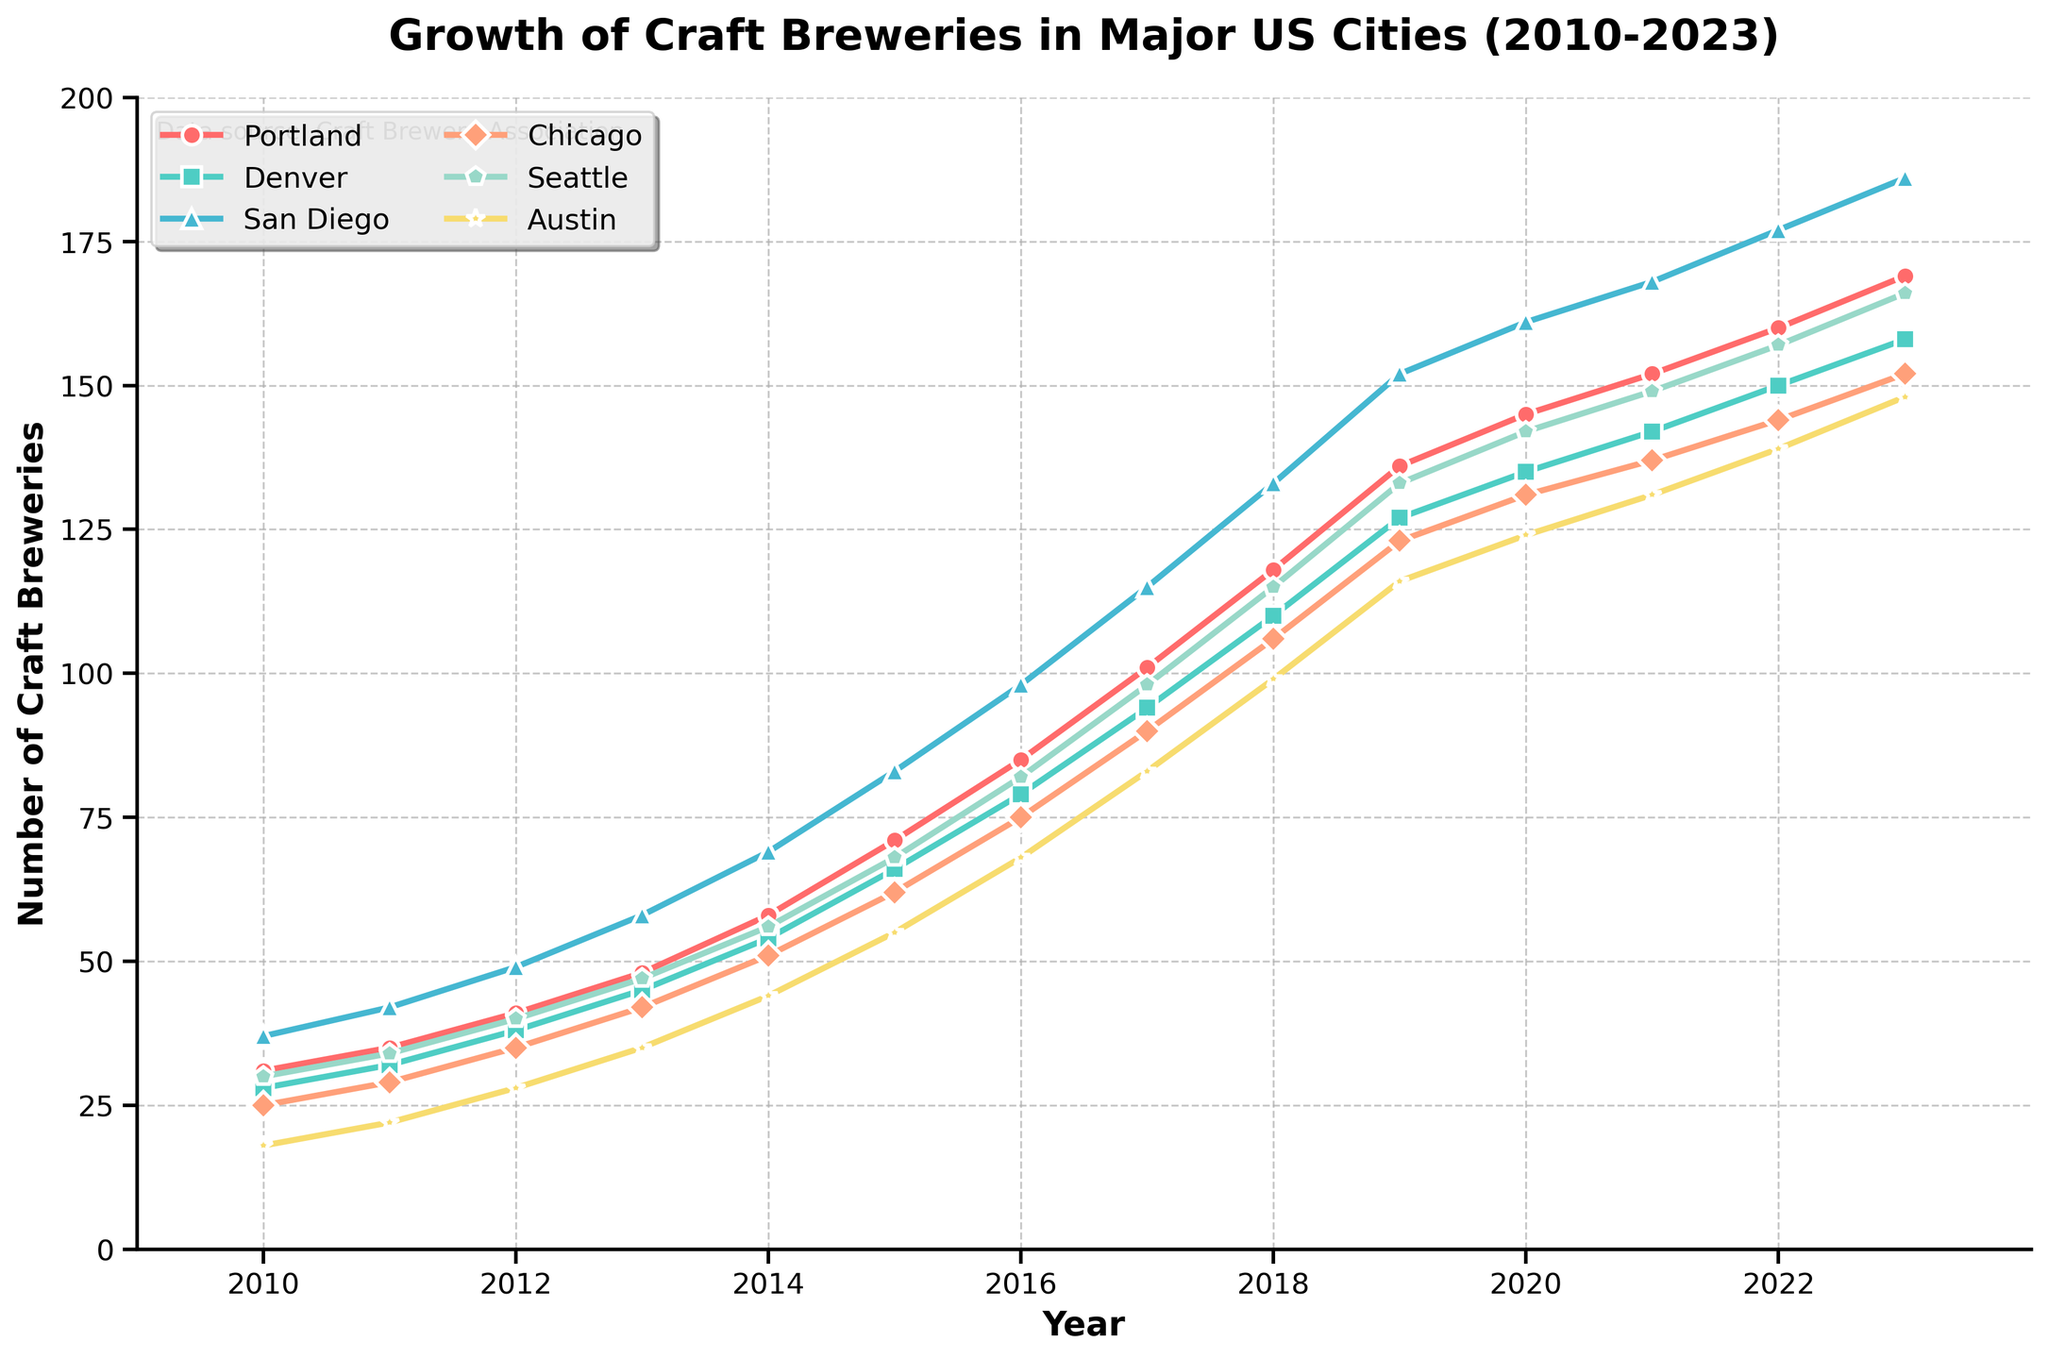What's the city with the highest number of craft breweries in 2023? By observing the endpoints of each line in 2023, we can see the highest point is for San Diego.
Answer: San Diego Compare the number of craft breweries between Denver and Austin in 2015. Which city has more, and by how many? In 2015, Denver has 66 craft breweries while Austin has 55. Subtracting 55 from 66 gives the difference of 11.
Answer: Denver by 11 In which year did Seattle reach 100 craft breweries? By tracking the increasing line for Seattle (greenish-blue line), we see that it crosses the 100 mark in 2017.
Answer: 2017 How many craft breweries were there in total in the six cities combined in 2018? Summing the number of craft breweries for each city in 2018: Portland (118) + Denver (110) + San Diego (133) + Chicago (106) + Seattle (115) + Austin (99) = 681.
Answer: 681 Which city had the most rapid increase in the number of craft breweries between 2010 and 2023? By comparing the slopes, we see San Diego has the steepest overall incline indicating the most rapid increase from 37 in 2010 to 186 in 2023.
Answer: San Diego In 2020, how many craft breweries are there in Chicago compared to Austin? In 2020, Chicago has 131 while Austin has 124. Thus, Chicago has more by 7.
Answer: Chicago by 7 What is the average number of craft breweries in Portland during the years 2010, 2013, and 2016? Adding the number of craft breweries for Portland in these years (31 in 2010, 48 in 2013, and 85 in 2016) and then dividing by 3 gives (31 + 48 + 85) / 3 = 54.67 (approximately).
Answer: 54.67 Which city had the smallest increase in the number of craft breweries between 2010 and 2015? Evaluating the differences for each city: Portland (71-31=40), Denver (66-28=38), San Diego (83-37=46), Chicago (62-25=37), Seattle (68-30=38), Austin (55-18=37). Chicago and Austin had the smallest increase of 37.
Answer: Chicago and Austin Between 2011 and 2012, which city had the highest percentage growth in craft breweries, and what was the percentage? For each city, calculate (increase / original number) * 100: 
- Portland: ((41-35)/35)*100 = 17.14%
- Denver: ((38-32)/32)*100 = 18.75%
- San Diego: ((49-42)/42) = 16.67%
- Chicago: ((35-29)/29) = 20.69%
- Seattle: ((40-34)/34) = 17.65%
- Austin: ((28-22)/22) = 27.27%
The highest percentage growth was in Austin.
Answer: Austin, 27.27% 